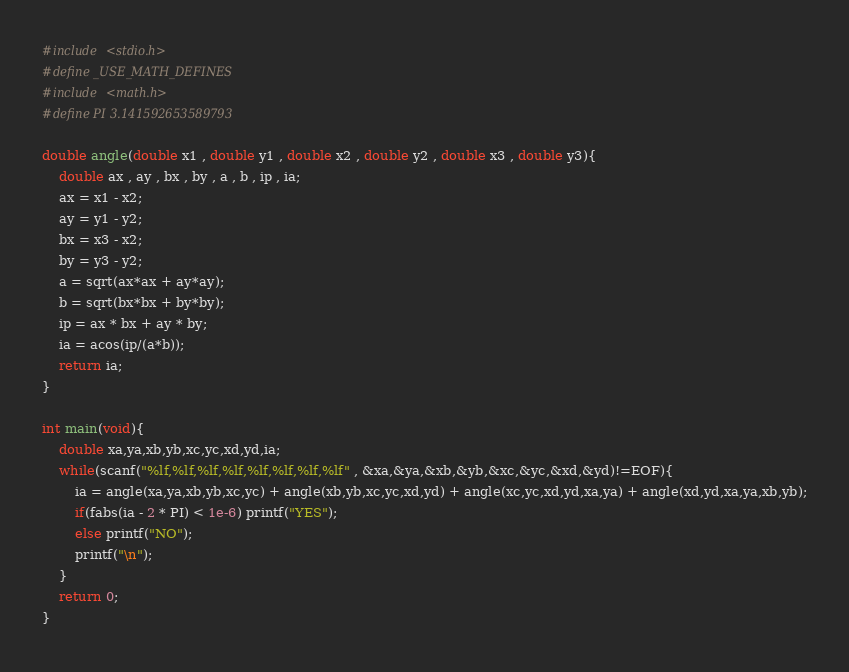<code> <loc_0><loc_0><loc_500><loc_500><_C_>#include <stdio.h>
#define _USE_MATH_DEFINES
#include <math.h>
#define PI 3.141592653589793

double angle(double x1 , double y1 , double x2 , double y2 , double x3 , double y3){
	double ax , ay , bx , by , a , b , ip , ia;
	ax = x1 - x2;
	ay = y1 - y2;
	bx = x3 - x2;
	by = y3 - y2;
	a = sqrt(ax*ax + ay*ay);
	b = sqrt(bx*bx + by*by);
	ip = ax * bx + ay * by;
	ia = acos(ip/(a*b));
	return ia;
}

int main(void){
	double xa,ya,xb,yb,xc,yc,xd,yd,ia;
	while(scanf("%lf,%lf,%lf,%lf,%lf,%lf,%lf,%lf" , &xa,&ya,&xb,&yb,&xc,&yc,&xd,&yd)!=EOF){
		ia = angle(xa,ya,xb,yb,xc,yc) + angle(xb,yb,xc,yc,xd,yd) + angle(xc,yc,xd,yd,xa,ya) + angle(xd,yd,xa,ya,xb,yb);
		if(fabs(ia - 2 * PI) < 1e-6) printf("YES");
		else printf("NO");
		printf("\n");
	}
	return 0;
}</code> 